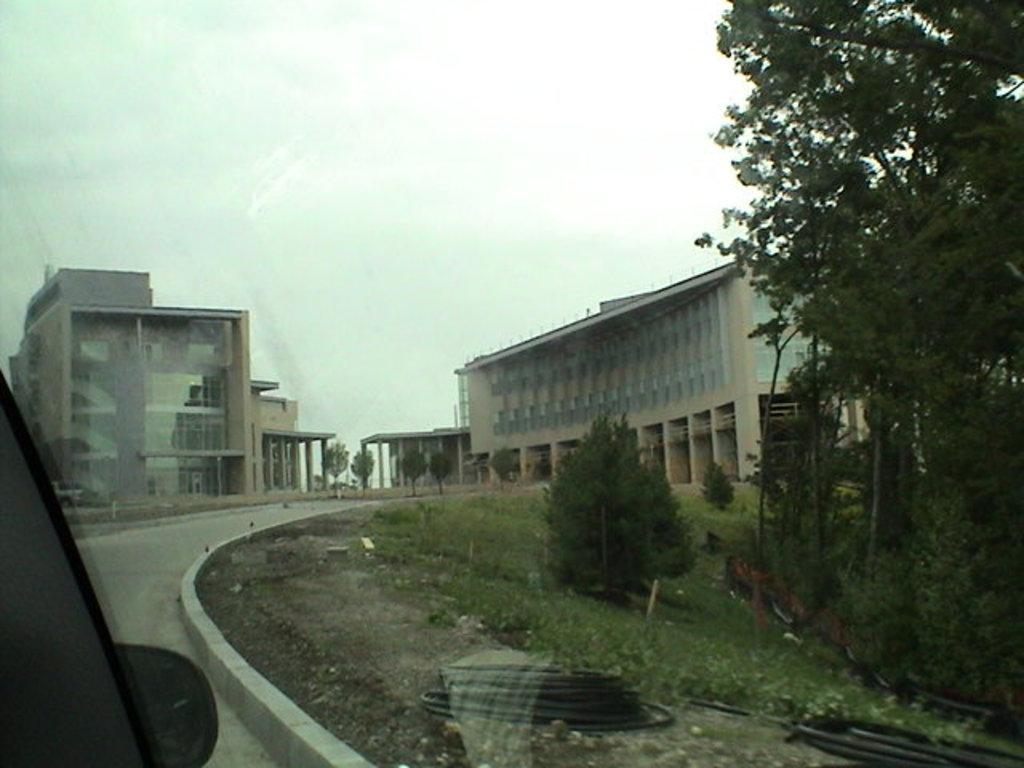What type of structures can be seen in the image? There are buildings in the image. What type of vegetation is present in the image? There are trees, plants, and grass in the image. What type of surface is visible in the image? There is a road in the image. What other objects can be seen in the image? There are other objects in the image, but their specific details are not mentioned in the provided facts. Where is the vehicle located in the image? The vehicle is on the left side of the image. How many hens are sitting on the tree in the image? There are no hens or trees present in the image; it features buildings, trees, plants, grass, a road, and a vehicle. What force is being applied to the vehicle in the image? There is no information about any force being applied to the vehicle in the image. 